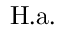<formula> <loc_0><loc_0><loc_500><loc_500>H . a .</formula> 